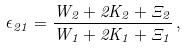Convert formula to latex. <formula><loc_0><loc_0><loc_500><loc_500>\epsilon _ { 2 1 } = \frac { W _ { 2 } + 2 K _ { 2 } + \Xi _ { 2 } } { W _ { 1 } + 2 K _ { 1 } + \Xi _ { 1 } } \, ,</formula> 